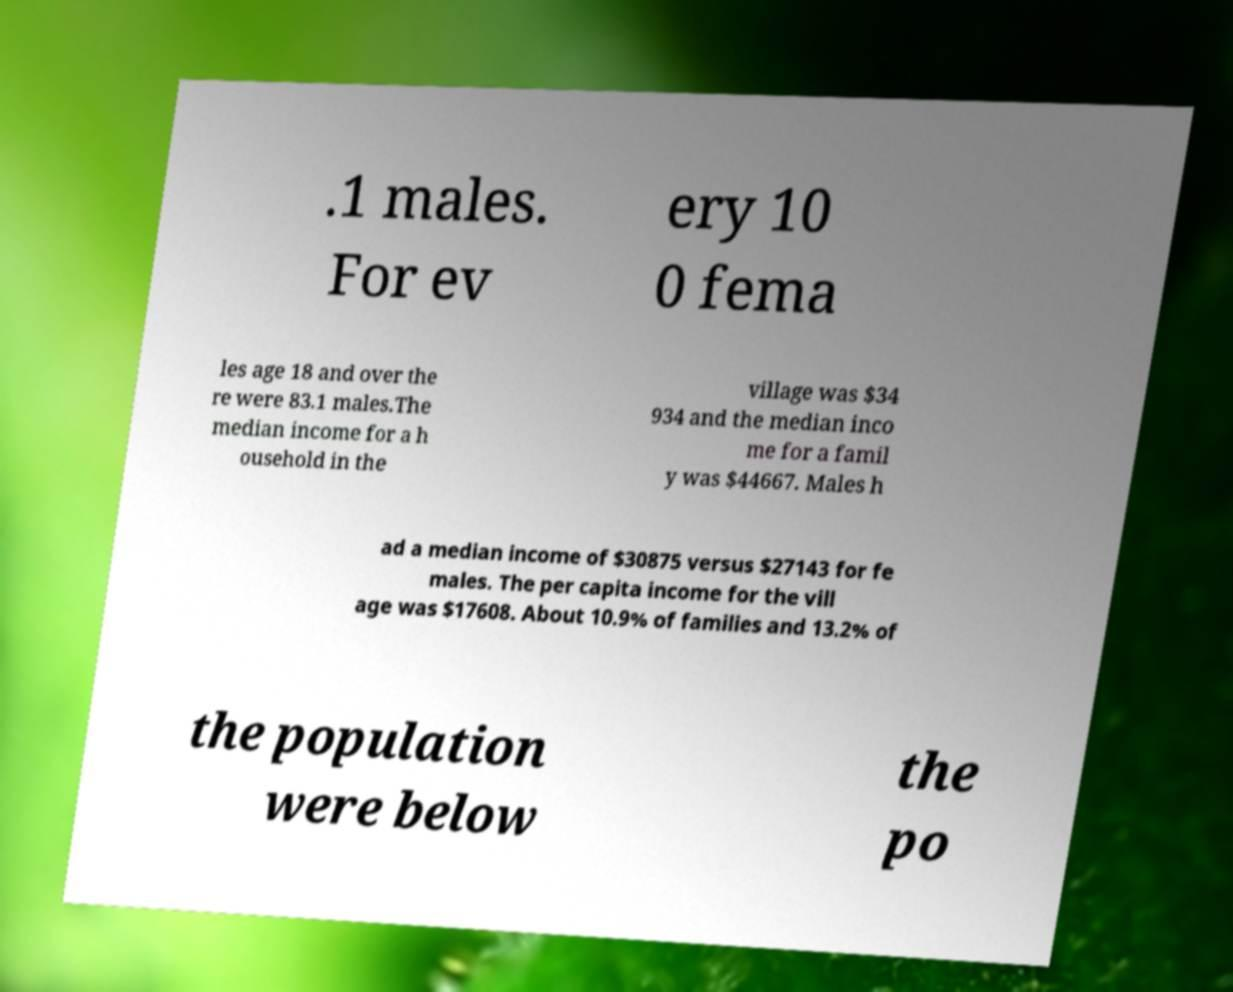Can you accurately transcribe the text from the provided image for me? .1 males. For ev ery 10 0 fema les age 18 and over the re were 83.1 males.The median income for a h ousehold in the village was $34 934 and the median inco me for a famil y was $44667. Males h ad a median income of $30875 versus $27143 for fe males. The per capita income for the vill age was $17608. About 10.9% of families and 13.2% of the population were below the po 